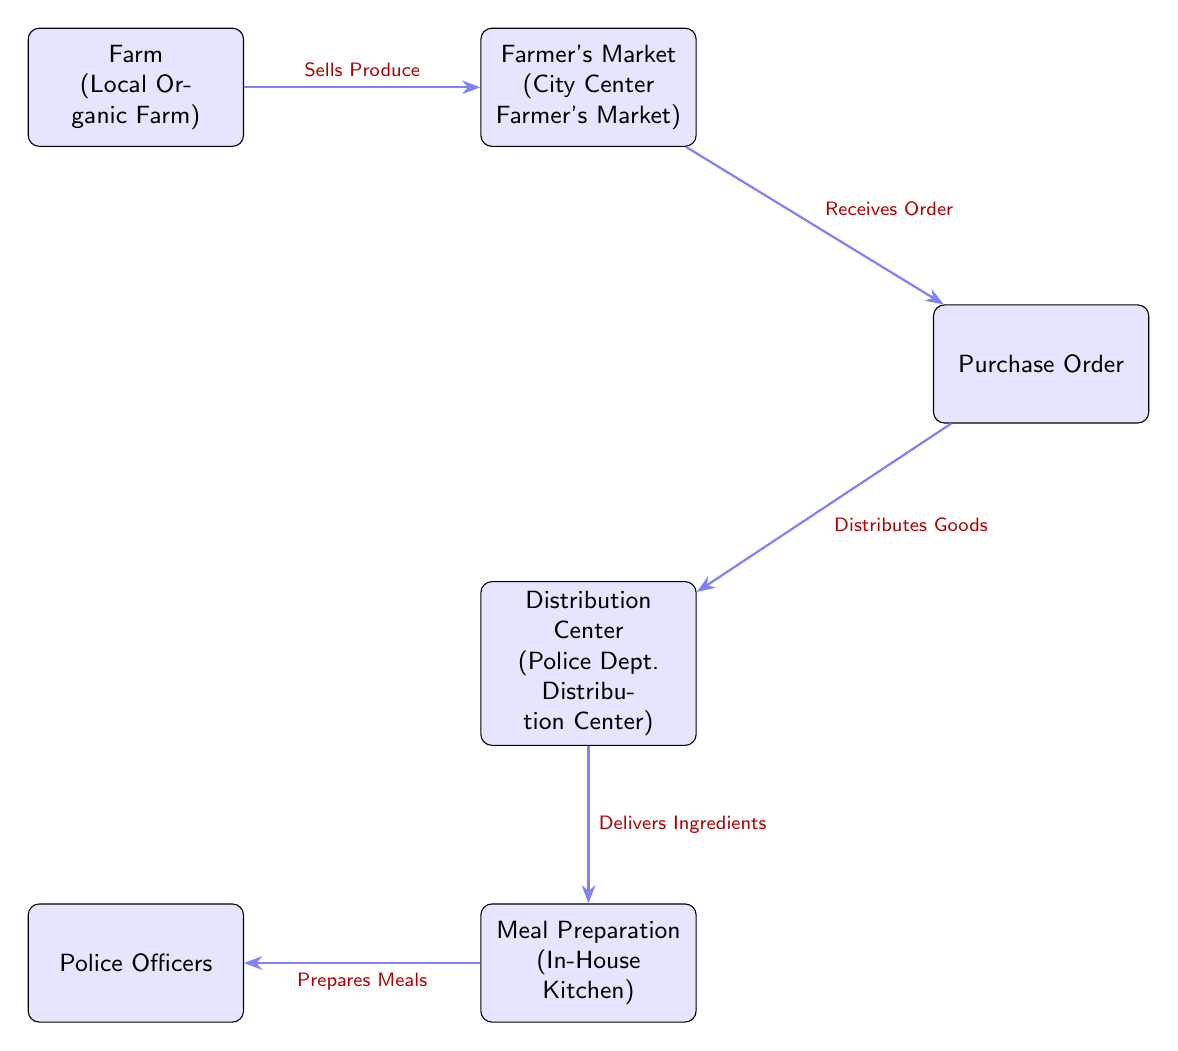What is the first node in the diagram? The diagram starts with the first node labeled as "Farm \\ (Local Organic Farm)," which indicates the source of produce.
Answer: Farm (Local Organic Farm) How many nodes are present in the food chain? By counting all distinct boxes in the diagram, we identify six nodes: Farm, Farmer's Market, Purchase Order, Distribution Center, Meal Preparation, and Police Officers.
Answer: 6 What does the Distribution Center do in the food chain? The arrow leading into the Distribution Center indicates that it "Distributes Goods" from the Purchase Order, playing a key role in the movement of products.
Answer: Distributes Goods What comes after Meal Preparation in the diagram? Following the Meal Preparation node, the arrow leads to the Police Officers node, indicating that meals are prepared for them.
Answer: Police Officers Which node receives an order from the Farmer's Market? The Purchase Order node receives (indicated by the arrow "Receives Order") goods from the Farmer's Market, facilitating the procurement process.
Answer: Purchase Order What type of farm produces the food? The diagram specifies "Local Organic Farm," describing the source of the ingredients used in the food chain.
Answer: Local Organic Farm What is the relationship between the Farmer's Market and the Purchase Order? The relationship is defined by the directional arrow stating that the Purchase Order "Receives Order" from the Farmer's Market, illustrating a transactional flow.
Answer: Receives Order How are meals prepared for the police officers? The Meal Preparation node indicates that meals are prepared in-house, specifically for the police officers based on ingredients supplied via the Distribution Center.
Answer: In-House Kitchen Which node is located directly below the Distribution Center? The diagram shows the Meal Preparation node directly below the Distribution Center, indicating the flow of ingredients for meal prep.
Answer: Meal Preparation What is the last step in the food chain shown in the diagram? The last step in this food chain is the preparation of meals, which are served to the Police Officers according to the flow of the diagram.
Answer: Prepares Meals 